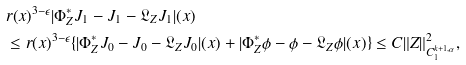Convert formula to latex. <formula><loc_0><loc_0><loc_500><loc_500>& r ( x ) ^ { 3 - \epsilon } | \Phi ^ { * } _ { Z } J _ { 1 } - J _ { 1 } - \mathfrak { L } _ { Z } J _ { 1 } | ( x ) \\ & \leq r ( x ) ^ { 3 - \epsilon } \{ | \Phi ^ { * } _ { Z } J _ { 0 } - J _ { 0 } - \mathfrak { L } _ { Z } J _ { 0 } | ( x ) + | \Phi ^ { * } _ { Z } \phi - \phi - \mathfrak { L } _ { Z } \phi | ( x ) \} \leq C \| Z \| _ { C ^ { k + 1 , \alpha } _ { 1 } } ^ { 2 } ,</formula> 